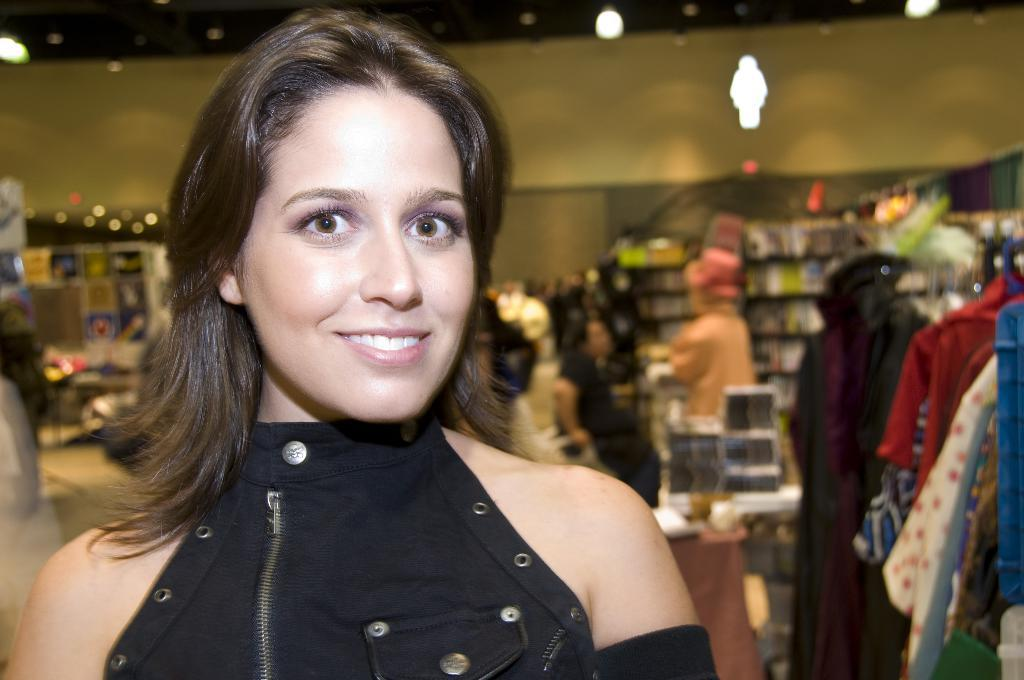Who is present in the image? There is a woman in the image. What is the woman's expression? The woman is smiling. What can be seen in the background of the image? There is a group of people, lights, clothes, and other items visible in the background of the image. What type of shade does the woman prefer to sit under in the image? There is no shade mentioned or visible in the image. What drink is the woman holding in the image? There is no drink visible in the image. 